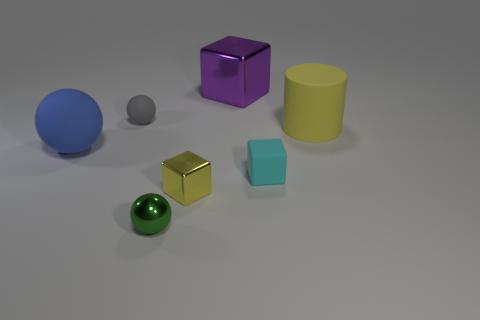Add 3 tiny yellow metallic things. How many objects exist? 10 Subtract all blocks. How many objects are left? 4 Subtract all small balls. Subtract all tiny yellow metallic objects. How many objects are left? 4 Add 1 yellow matte cylinders. How many yellow matte cylinders are left? 2 Add 4 big gray matte cubes. How many big gray matte cubes exist? 4 Subtract 0 cyan spheres. How many objects are left? 7 